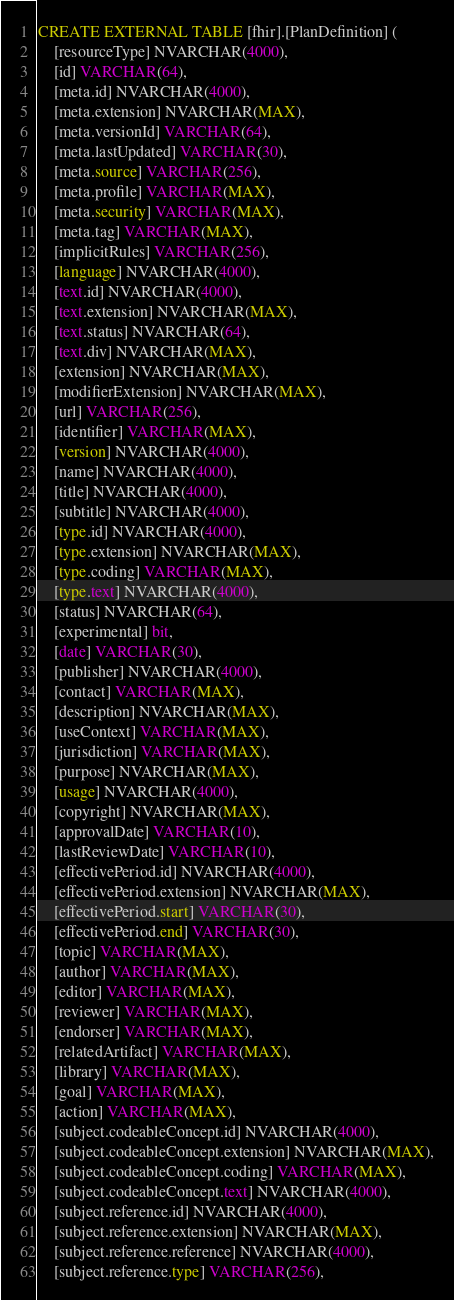Convert code to text. <code><loc_0><loc_0><loc_500><loc_500><_SQL_>CREATE EXTERNAL TABLE [fhir].[PlanDefinition] (
    [resourceType] NVARCHAR(4000),
    [id] VARCHAR(64),
    [meta.id] NVARCHAR(4000),
    [meta.extension] NVARCHAR(MAX),
    [meta.versionId] VARCHAR(64),
    [meta.lastUpdated] VARCHAR(30),
    [meta.source] VARCHAR(256),
    [meta.profile] VARCHAR(MAX),
    [meta.security] VARCHAR(MAX),
    [meta.tag] VARCHAR(MAX),
    [implicitRules] VARCHAR(256),
    [language] NVARCHAR(4000),
    [text.id] NVARCHAR(4000),
    [text.extension] NVARCHAR(MAX),
    [text.status] NVARCHAR(64),
    [text.div] NVARCHAR(MAX),
    [extension] NVARCHAR(MAX),
    [modifierExtension] NVARCHAR(MAX),
    [url] VARCHAR(256),
    [identifier] VARCHAR(MAX),
    [version] NVARCHAR(4000),
    [name] NVARCHAR(4000),
    [title] NVARCHAR(4000),
    [subtitle] NVARCHAR(4000),
    [type.id] NVARCHAR(4000),
    [type.extension] NVARCHAR(MAX),
    [type.coding] VARCHAR(MAX),
    [type.text] NVARCHAR(4000),
    [status] NVARCHAR(64),
    [experimental] bit,
    [date] VARCHAR(30),
    [publisher] NVARCHAR(4000),
    [contact] VARCHAR(MAX),
    [description] NVARCHAR(MAX),
    [useContext] VARCHAR(MAX),
    [jurisdiction] VARCHAR(MAX),
    [purpose] NVARCHAR(MAX),
    [usage] NVARCHAR(4000),
    [copyright] NVARCHAR(MAX),
    [approvalDate] VARCHAR(10),
    [lastReviewDate] VARCHAR(10),
    [effectivePeriod.id] NVARCHAR(4000),
    [effectivePeriod.extension] NVARCHAR(MAX),
    [effectivePeriod.start] VARCHAR(30),
    [effectivePeriod.end] VARCHAR(30),
    [topic] VARCHAR(MAX),
    [author] VARCHAR(MAX),
    [editor] VARCHAR(MAX),
    [reviewer] VARCHAR(MAX),
    [endorser] VARCHAR(MAX),
    [relatedArtifact] VARCHAR(MAX),
    [library] VARCHAR(MAX),
    [goal] VARCHAR(MAX),
    [action] VARCHAR(MAX),
    [subject.codeableConcept.id] NVARCHAR(4000),
    [subject.codeableConcept.extension] NVARCHAR(MAX),
    [subject.codeableConcept.coding] VARCHAR(MAX),
    [subject.codeableConcept.text] NVARCHAR(4000),
    [subject.reference.id] NVARCHAR(4000),
    [subject.reference.extension] NVARCHAR(MAX),
    [subject.reference.reference] NVARCHAR(4000),
    [subject.reference.type] VARCHAR(256),</code> 